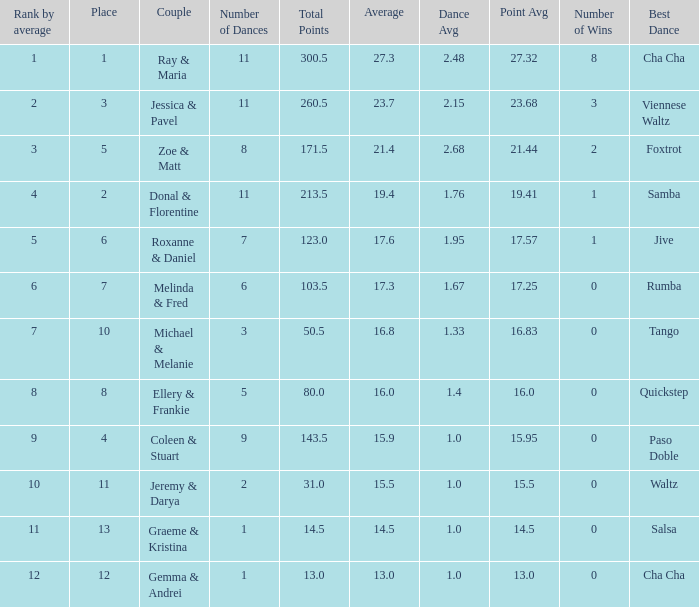If your rank by average is 9, what is the name of the couple? Coleen & Stuart. 